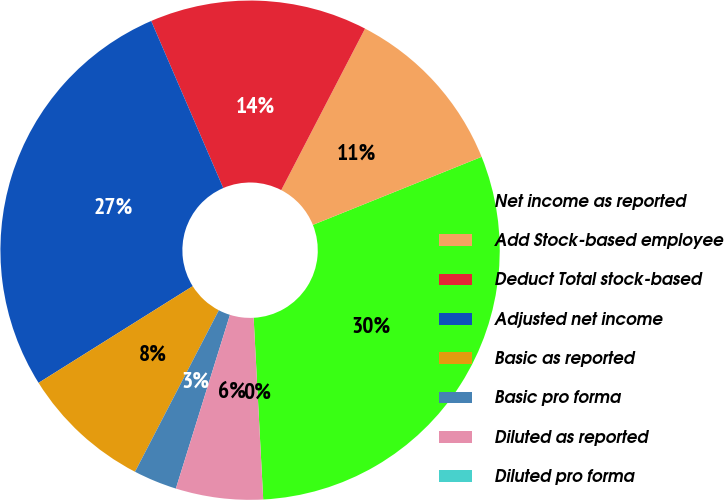Convert chart. <chart><loc_0><loc_0><loc_500><loc_500><pie_chart><fcel>Net income as reported<fcel>Add Stock-based employee<fcel>Deduct Total stock-based<fcel>Adjusted net income<fcel>Basic as reported<fcel>Basic pro forma<fcel>Diluted as reported<fcel>Diluted pro forma<nl><fcel>30.26%<fcel>11.28%<fcel>14.1%<fcel>27.43%<fcel>8.46%<fcel>2.82%<fcel>5.64%<fcel>0.0%<nl></chart> 